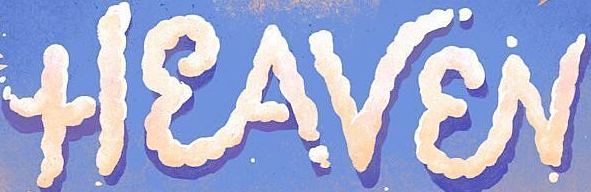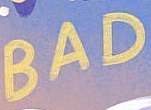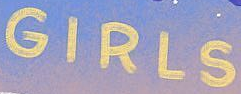Read the text content from these images in order, separated by a semicolon. HEAVEN; BAD; GIRLS 